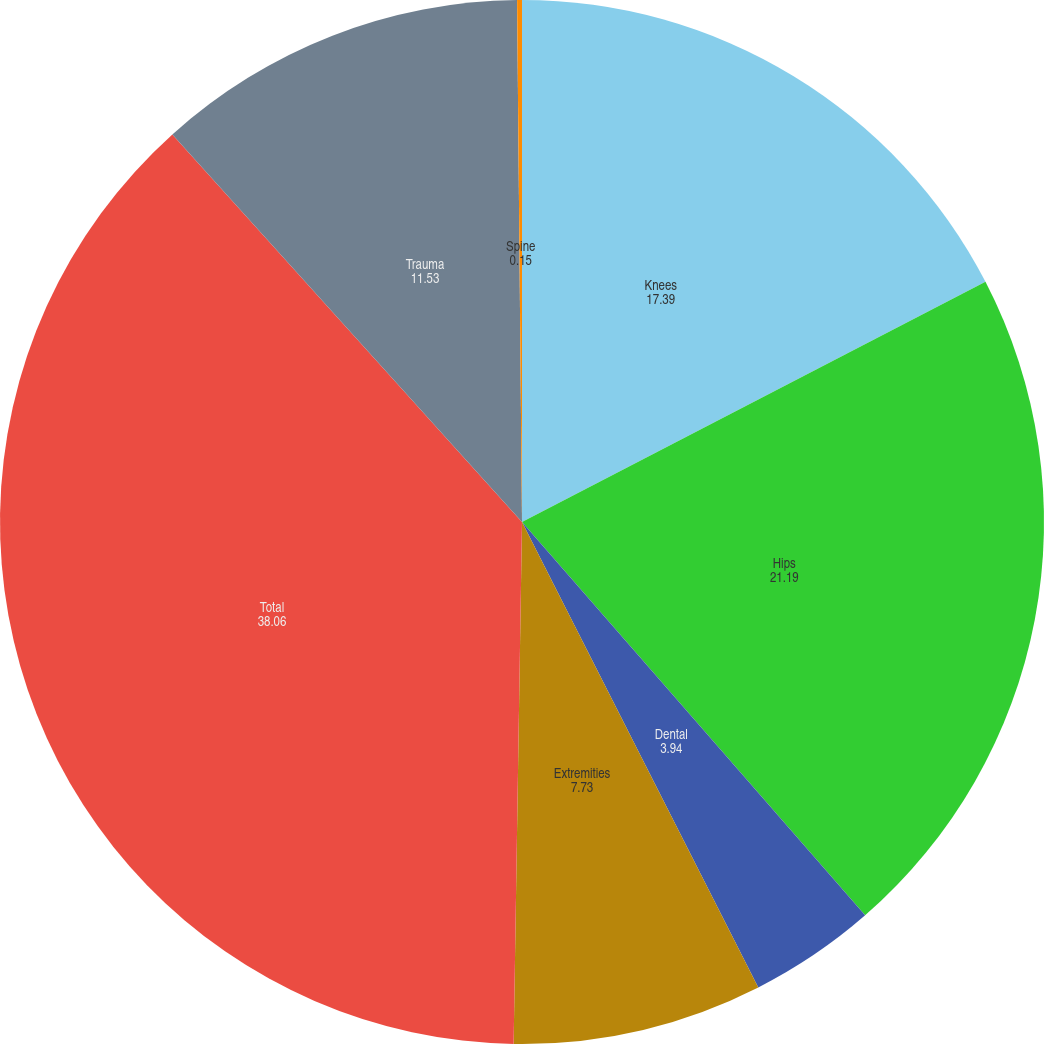<chart> <loc_0><loc_0><loc_500><loc_500><pie_chart><fcel>Knees<fcel>Hips<fcel>Dental<fcel>Extremities<fcel>Total<fcel>Trauma<fcel>Spine<nl><fcel>17.39%<fcel>21.19%<fcel>3.94%<fcel>7.73%<fcel>38.06%<fcel>11.53%<fcel>0.15%<nl></chart> 